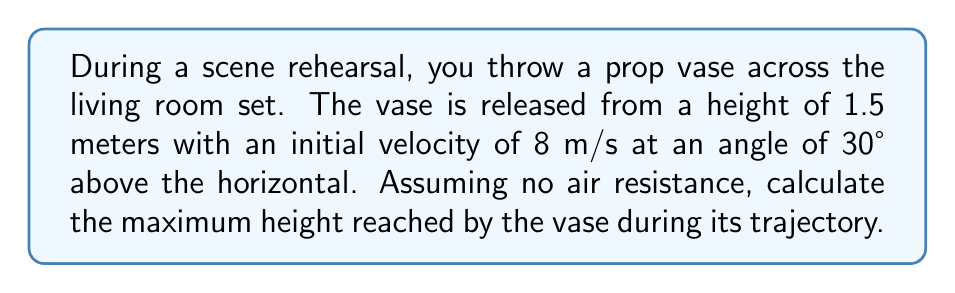Solve this math problem. To solve this problem, we'll use the principles of projectile motion. Let's break it down step-by-step:

1) First, we need to find the vertical component of the initial velocity:
   $v_{y0} = v_0 \sin \theta = 8 \text{ m/s} \cdot \sin 30° = 4 \text{ m/s}$

2) The maximum height is reached when the vertical velocity becomes zero. We can use the equation:
   $v_y^2 = v_{y0}^2 - 2g\Delta y$

   Where $v_y = 0$ at the highest point, $g = 9.8 \text{ m/s}^2$, and $\Delta y$ is the change in height from the release point to the maximum height.

3) Substituting these values:
   $0^2 = (4 \text{ m/s})^2 - 2(9.8 \text{ m/s}^2)\Delta y$

4) Solving for $\Delta y$:
   $\Delta y = \frac{(4 \text{ m/s})^2}{2(9.8 \text{ m/s}^2)} = 0.816 \text{ m}$

5) The vase was released from a height of 1.5 m, so the maximum height is:
   $h_{max} = 1.5 \text{ m} + 0.816 \text{ m} = 2.316 \text{ m}$

Therefore, the maximum height reached by the vase is approximately 2.32 meters.
Answer: 2.32 m 